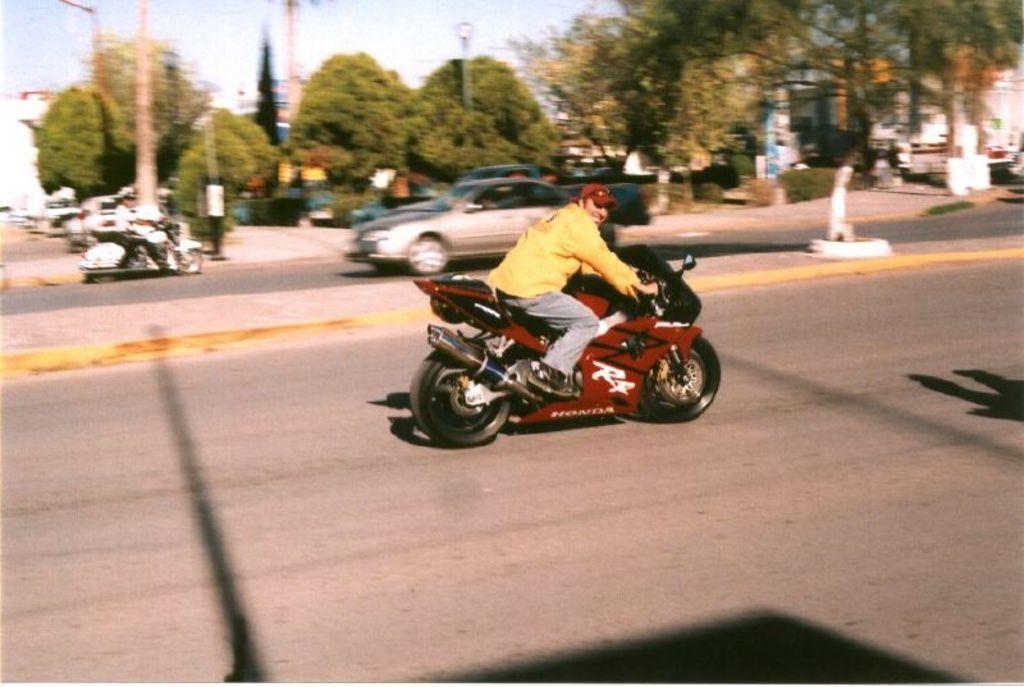Who is the main subject in the image? There is a man in the image. What is the man doing in the image? The man is riding a bike. Where is the image taken? The image is taken on a road. What can be seen in the background of the image? There are trees and cars in the background of the image. What type of locket is the man wearing around his neck in the image? There is no locket visible around the man's neck in the image. How much dirt is present on the road in the image? The image does not provide information about the amount of dirt on the road. 